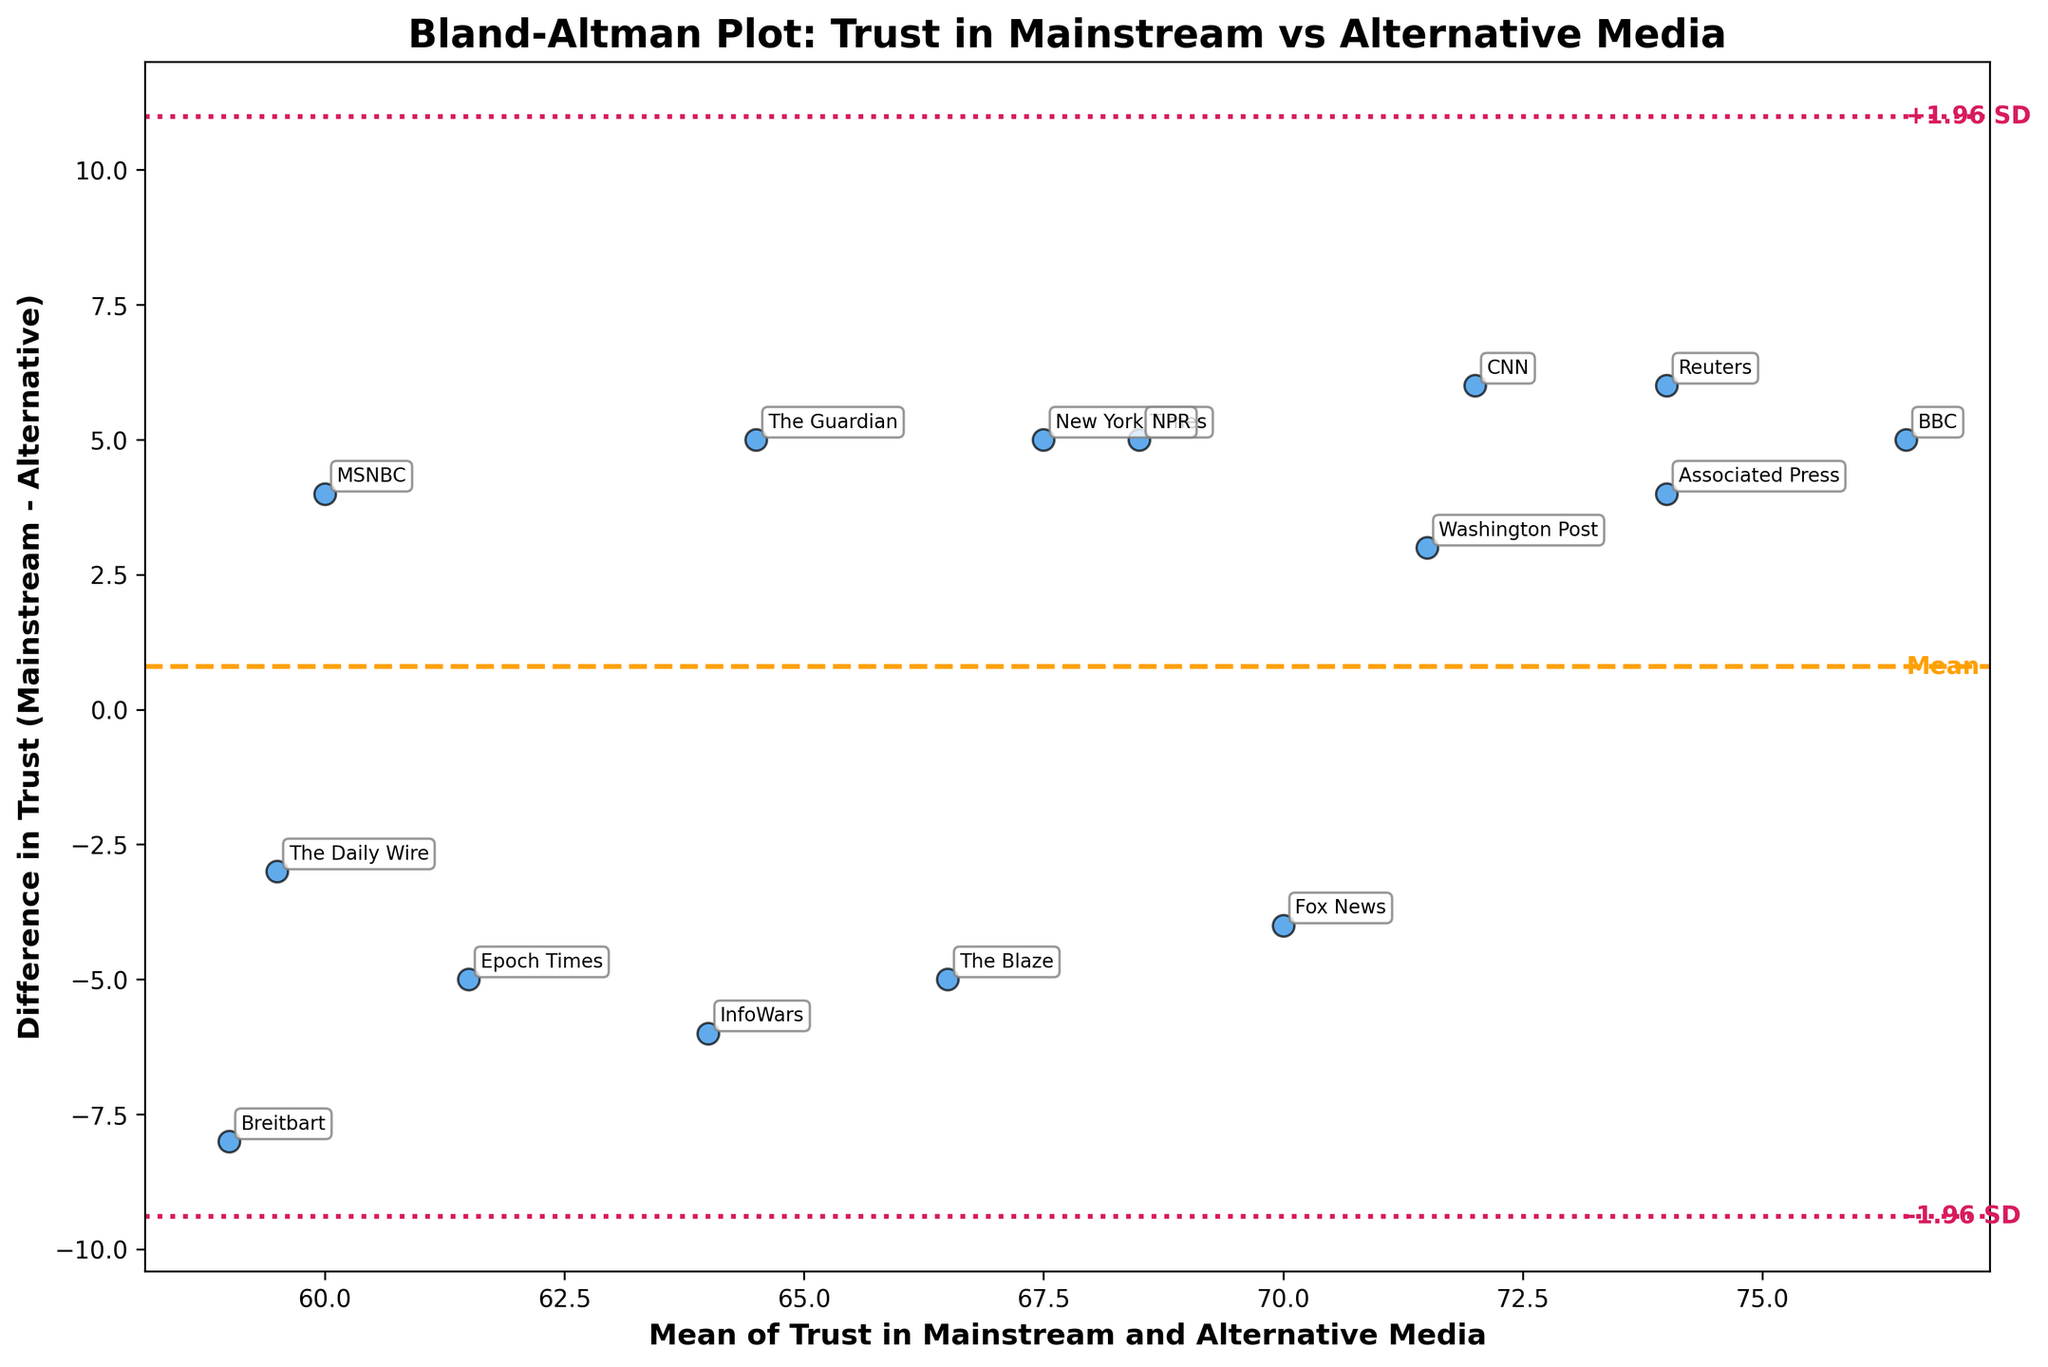How many data points are there in the figure? To determine the number of data points, look at the number of individual points marked on the scatter plot. Each point represents a news outlet, and there are 15 points.
Answer: 15 What is the title of the plot? The title of the plot is prominently displayed at the top of the figure.
Answer: Bland-Altman Plot: Trust in Mainstream vs Alternative Media What do the horizontal lines on the plot represent? The plot has three horizontal lines: one represents the mean difference (dashed line), and the other two represent the limits of agreement (dotted lines), which are the mean difference ± 1.96 times the standard deviation of the differences.
Answer: Mean difference and limits of agreement Which news outlet has the highest trust difference between mainstream and alternative media? To find the news outlet with the highest trust difference, look for the point that is furthest from the zero line on the y-axis. In this case, "Breitbart" has the largest positive difference.
Answer: Breitbart What's the average difference in trust between mainstream and alternative news outlets? The average difference is indicated by the dashed horizontal line in the figure, which marks the mean difference. The exact value can be seen aligned with this horizontal line on the y-axis.
Answer: 2.4 What's the difference in trust for CNN? Locate the point labeled "CNN" on the scatter plot and read its y-axis value, which represents the difference in trust between CNN in mainstream and alternative media.
Answer: 6 Which news outlet has the mean trust closest to 70? Identify the point on the x-axis (mean trust) that is closest to 70 and note the associated news outlet label. In this case, "Reuters" is closest to a mean trust of 70.
Answer: Reuters For Fox News, is public trust higher in mainstream media or alternative media? Look at the point labeled "Fox News" and check the y-axis value (difference in trust). If the value is negative, trust is higher in alternative media; if positive, trust is higher in mainstream media. The value is negative, indicating higher trust in alternative media.
Answer: Alternative media What is the range spanned by the limits of agreement on the y-axis? The limits of agreement are the dotted lines and are calculated as the mean difference ± 1.96 times the standard deviation of the differences. The range these lines span can be seen from the lowest limit to the highest limit.
Answer: -7.8 to 12.6 